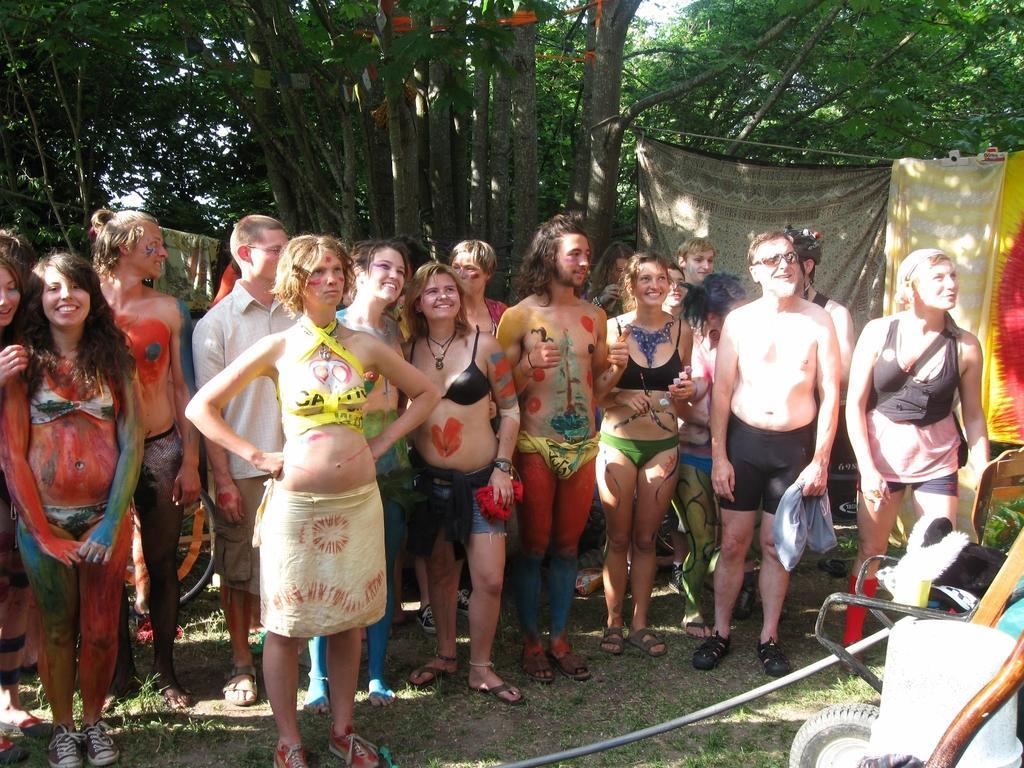Describe this image in one or two sentences. In the image we can see there are many people standing, they are wearing clothes, some of them are wearing shoes, and some of them are wearing slippers. This is an object, grass, trees, cloth and a sky. 